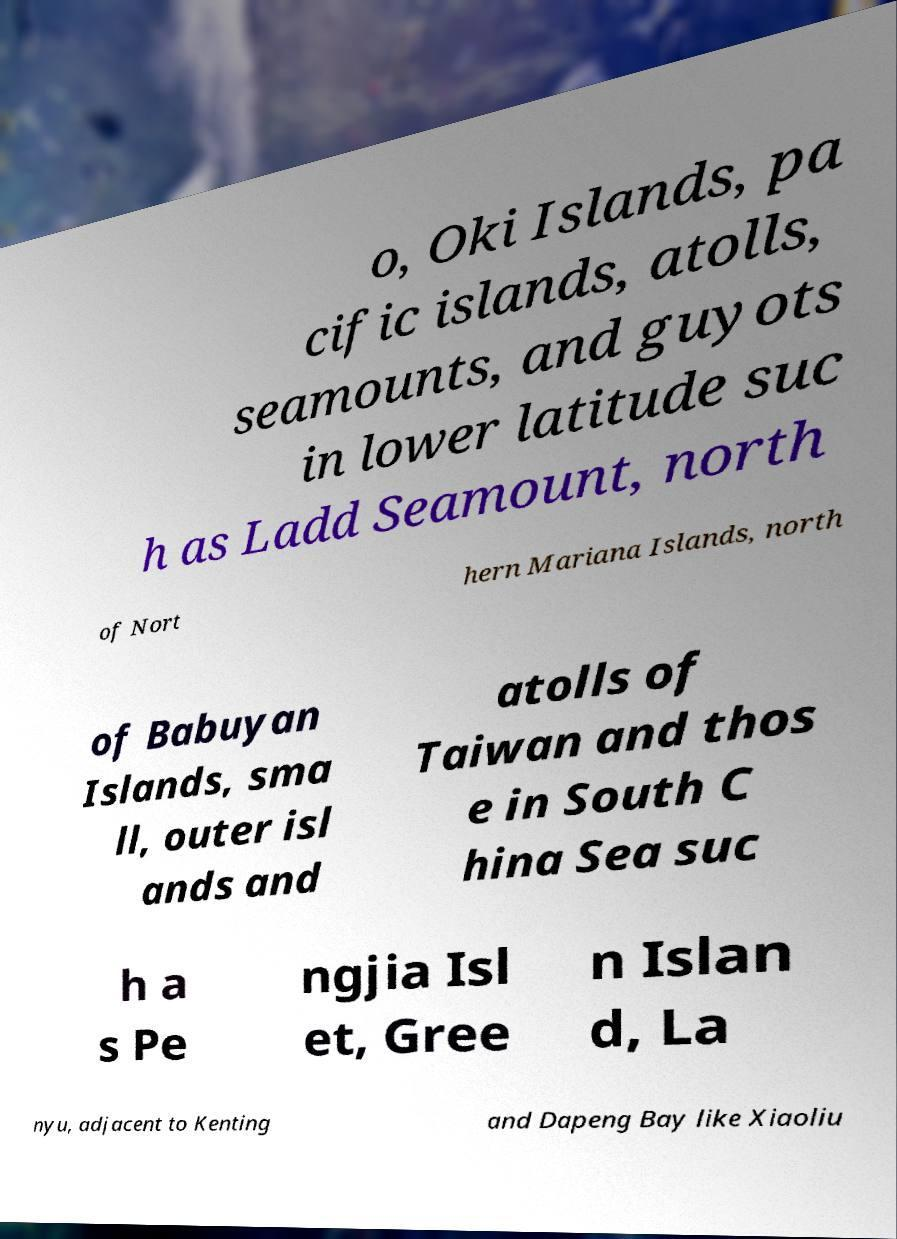Please identify and transcribe the text found in this image. o, Oki Islands, pa cific islands, atolls, seamounts, and guyots in lower latitude suc h as Ladd Seamount, north of Nort hern Mariana Islands, north of Babuyan Islands, sma ll, outer isl ands and atolls of Taiwan and thos e in South C hina Sea suc h a s Pe ngjia Isl et, Gree n Islan d, La nyu, adjacent to Kenting and Dapeng Bay like Xiaoliu 